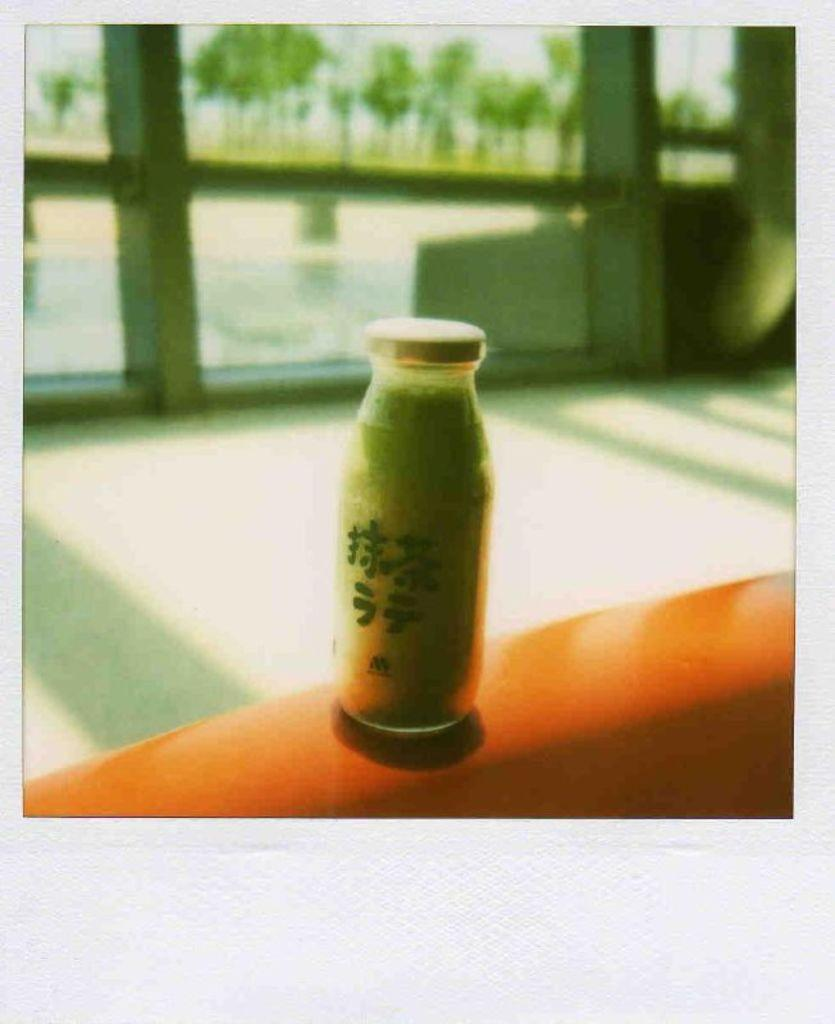What object is visible in the image that is typically used for holding liquids? There is a bottle in the image. Where is the bottle located? The bottle is kept on a wall. What is the color of the wall? The wall is orange in color. What type of architectural feature can be seen in the background of the image? There is a glass window in the background of the image. What is the color of the glass window? The glass window is white in color. What type of calendar is hanging on the wall next to the bottle? There is no calendar present in the image; only the bottle, the orange wall, and the white glass window are visible. 